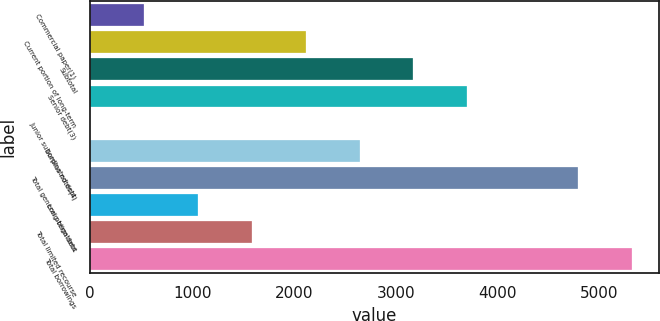Convert chart. <chart><loc_0><loc_0><loc_500><loc_500><bar_chart><fcel>Commercial paper(1)<fcel>Current portion of long-term<fcel>Subtotal<fcel>Senior debt(3)<fcel>Junior subordinated debt<fcel>Surplus notes(4)<fcel>Total general obligations<fcel>Long-term debt<fcel>Total limited recourse<fcel>Total borrowings<nl><fcel>530.04<fcel>2116.7<fcel>3174.48<fcel>3703.37<fcel>1.15<fcel>2645.59<fcel>4788<fcel>1058.93<fcel>1587.82<fcel>5316.89<nl></chart> 